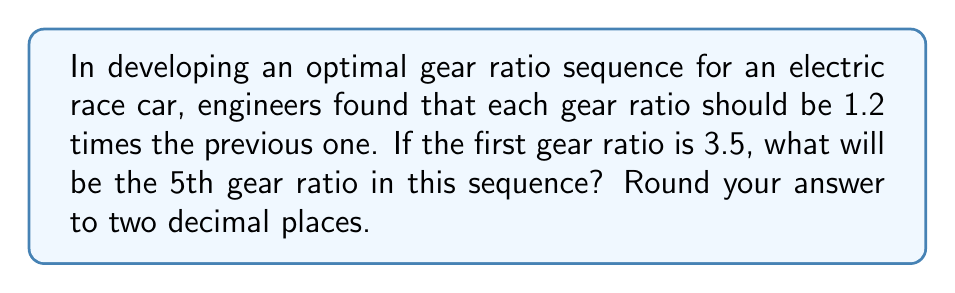What is the answer to this math problem? Let's approach this step-by-step:

1) We're given that each gear ratio is 1.2 times the previous one. This forms a geometric sequence with a common ratio of 1.2.

2) The first term in the sequence (a₁) is 3.5.

3) We need to find the 5th term (a₅).

4) In a geometric sequence, the nth term is given by the formula:

   $$ a_n = a_1 \cdot r^{n-1} $$

   Where:
   $a_n$ is the nth term
   $a_1$ is the first term
   $r$ is the common ratio
   $n$ is the position of the term

5) Substituting our values:

   $$ a_5 = 3.5 \cdot 1.2^{5-1} = 3.5 \cdot 1.2^4 $$

6) Calculate:

   $$ a_5 = 3.5 \cdot (1.2 \cdot 1.2 \cdot 1.2 \cdot 1.2) $$
   $$ a_5 = 3.5 \cdot 2.0736 $$
   $$ a_5 = 7.2576 $$

7) Rounding to two decimal places:

   $$ a_5 \approx 7.26 $$

Thus, the 5th gear ratio in the sequence will be approximately 7.26.
Answer: 7.26 